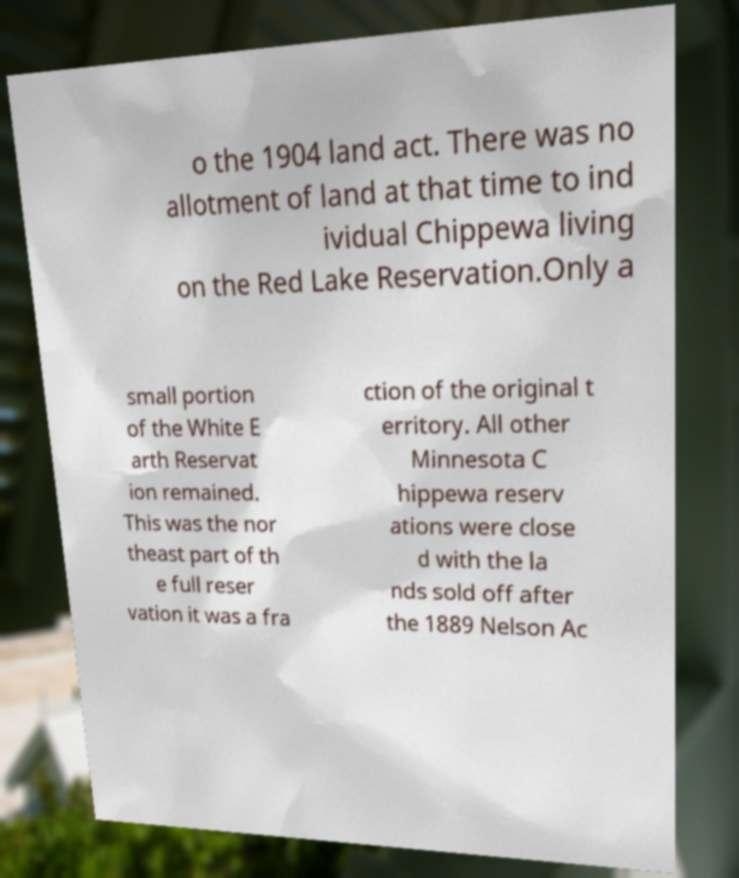There's text embedded in this image that I need extracted. Can you transcribe it verbatim? o the 1904 land act. There was no allotment of land at that time to ind ividual Chippewa living on the Red Lake Reservation.Only a small portion of the White E arth Reservat ion remained. This was the nor theast part of th e full reser vation it was a fra ction of the original t erritory. All other Minnesota C hippewa reserv ations were close d with the la nds sold off after the 1889 Nelson Ac 